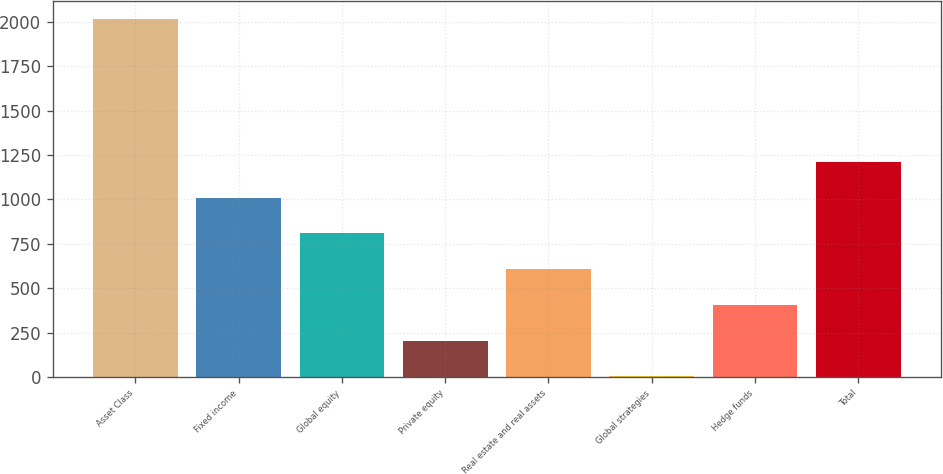<chart> <loc_0><loc_0><loc_500><loc_500><bar_chart><fcel>Asset Class<fcel>Fixed income<fcel>Global equity<fcel>Private equity<fcel>Real estate and real assets<fcel>Global strategies<fcel>Hedge funds<fcel>Total<nl><fcel>2014<fcel>1009<fcel>808<fcel>205<fcel>607<fcel>4<fcel>406<fcel>1210<nl></chart> 